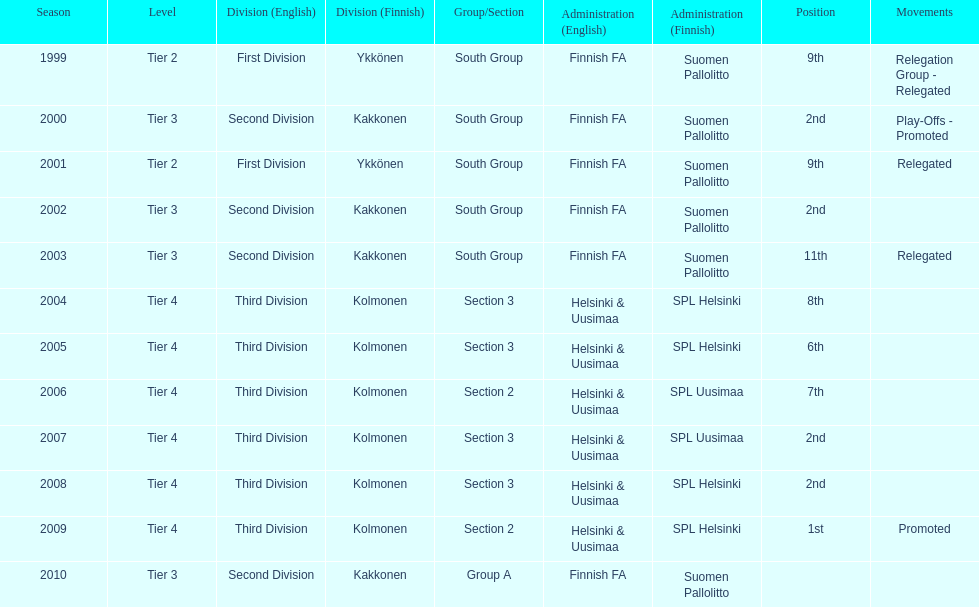Of the third division, how many were in section3? 4. 